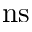<formula> <loc_0><loc_0><loc_500><loc_500>n s</formula> 